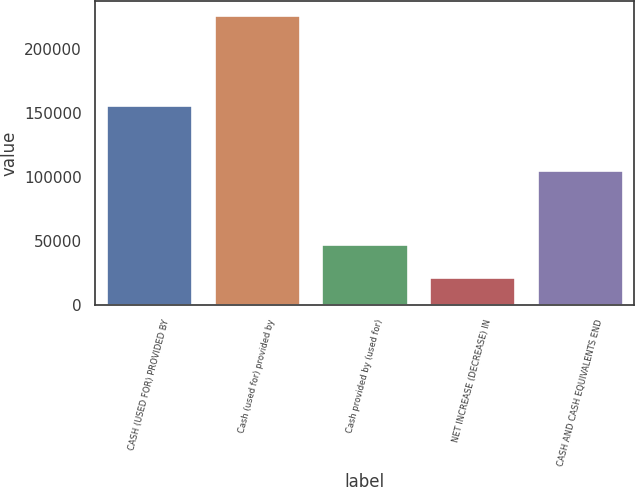Convert chart. <chart><loc_0><loc_0><loc_500><loc_500><bar_chart><fcel>CASH (USED FOR) PROVIDED BY<fcel>Cash (used for) provided by<fcel>Cash provided by (used for)<fcel>NET INCREASE (DECREASE) IN<fcel>CASH AND CASH EQUIVALENTS END<nl><fcel>156386<fcel>226046<fcel>47833<fcel>21827<fcel>105465<nl></chart> 